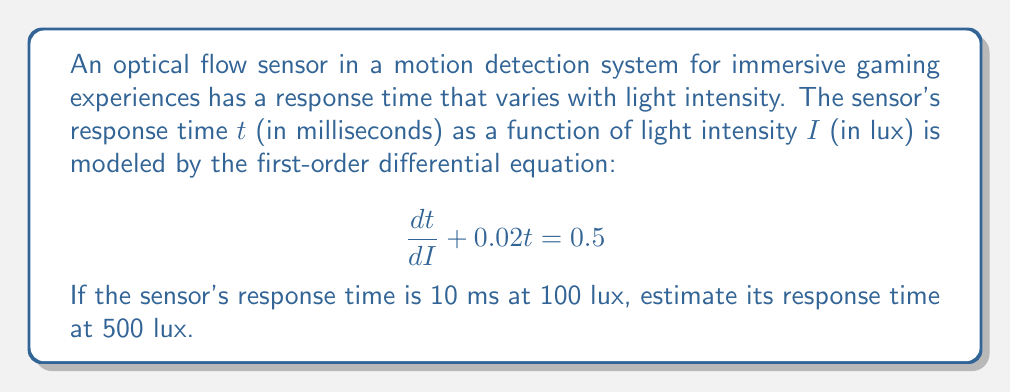Can you answer this question? To solve this problem, we need to follow these steps:

1) First, we recognize this as a first-order linear differential equation in the form:

   $$\frac{dy}{dx} + P(x)y = Q(x)$$

   where $y = t$, $x = I$, $P(I) = 0.02$, and $Q(I) = 0.5$

2) The general solution for this type of equation is:

   $$y = e^{-\int P(x)dx} \left(\int Q(x)e^{\int P(x)dx}dx + C\right)$$

3) Let's solve it step by step:
   
   $\int P(I)dI = \int 0.02 dI = 0.02I$
   
   $e^{\int P(I)dI} = e^{0.02I}$

4) Now we can write the general solution:

   $$t = e^{-0.02I} \left(\int 0.5e^{0.02I}dI + C\right)$$

5) Solving the integral:

   $$t = e^{-0.02I} \left(25e^{0.02I} + C\right) = 25 + Ce^{-0.02I}$$

6) We're given that $t = 10$ when $I = 100$. Let's use this to find $C$:

   $$10 = 25 + Ce^{-0.02(100)}$$
   $$C = (10 - 25)e^{2} = -15e^{2}$$

7) So our particular solution is:

   $$t = 25 - 15e^{2-0.02I}$$

8) Now we can find $t$ when $I = 500$:

   $$t = 25 - 15e^{2-0.02(500)} = 25 - 15e^{-8} \approx 24.999$$

Therefore, the estimated response time at 500 lux is approximately 25 ms.
Answer: 25 ms 